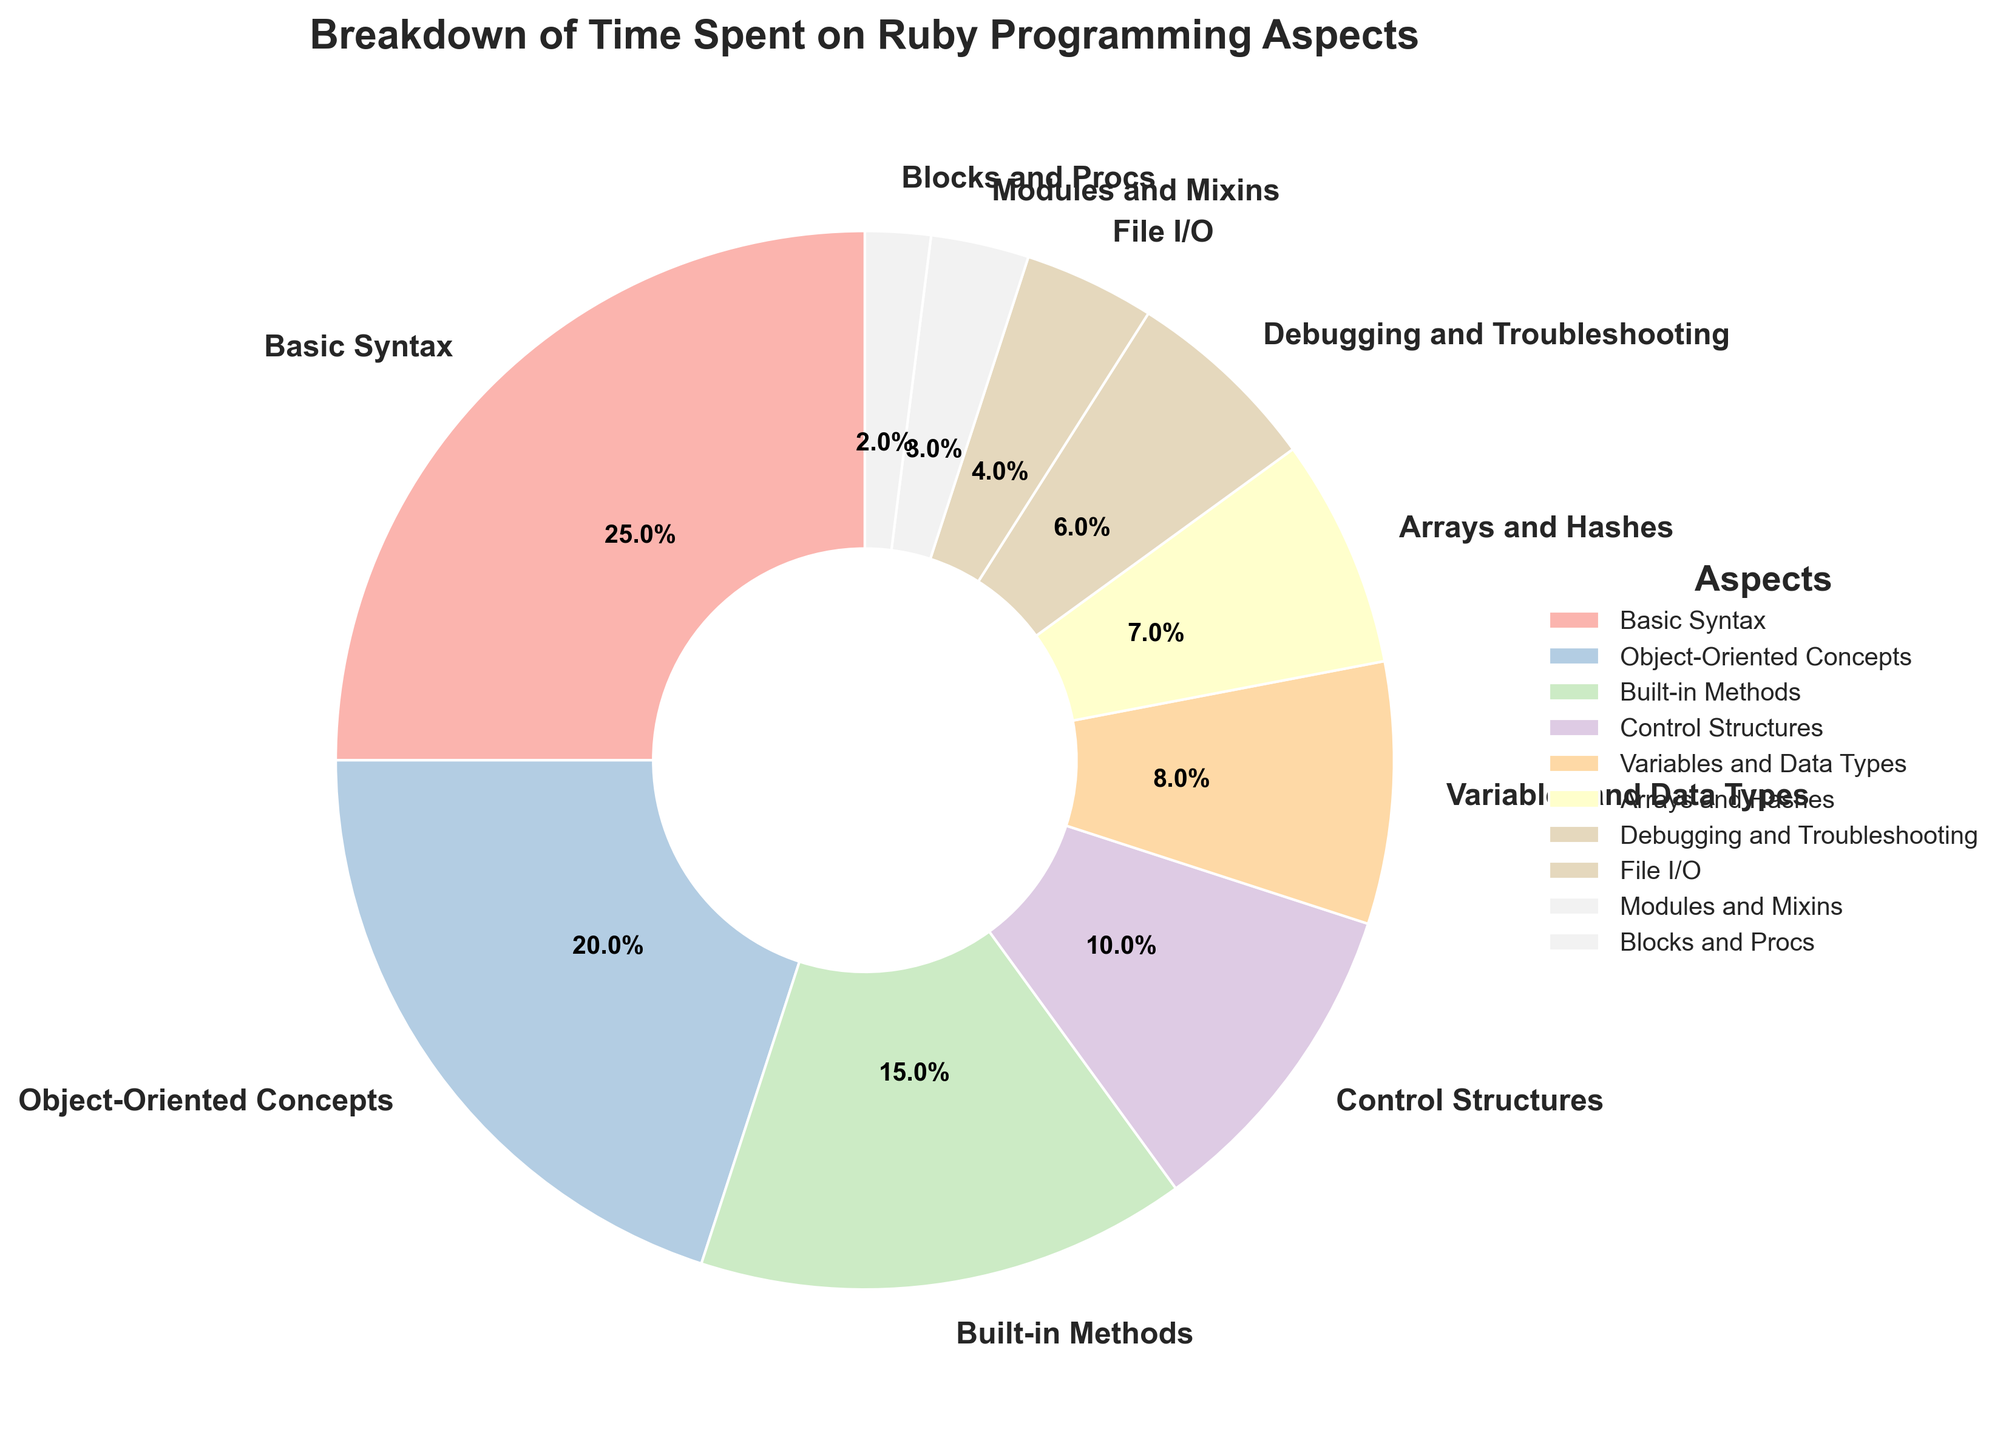What's the total percentage spent on learning control structures and variables and data types? To find the total percentage, add the provided percentages for Control Structures (10) and Variables and Data Types (8). 10 + 8 = 18
Answer: 18% Which aspect takes up more time: debugging and troubleshooting or arrays and hashes? Compare the percentage values for Debugging and Troubleshooting (6) and Arrays and Hashes (7). Arrays and Hashes (7) is greater.
Answer: Arrays and Hashes How much more time is spent on object-oriented concepts compared to built-in methods? Subtract the percentage for Built-in Methods (15) from Object-Oriented Concepts (20). 20 - 15 = 5
Answer: 5% What's the combined percentage of time spent on modules and mixins, and blocks and procs? Add the percentages for Modules and Mixins (3) and Blocks and Procs (2). 3 + 2 = 5
Answer: 5% Which aspect requires the least amount of time? Identify the smallest percentage in the chart, which is for Blocks and Procs (2).
Answer: Blocks and Procs Are Variables and Data Types given more attention than File I/O? Compare the percentages for Variables and Data Types (8) and File I/O (4). Variables and Data Types (8) is greater.
Answer: Yes Is the time spent on array and hashes more than half of the time spent on basic syntax? Divide the percentage for Basic Syntax (25) by 2 to get 12.5. Compare this value with Arrays and Hashes (7). 7 < 12.5
Answer: No What is the difference between the time spent on learning control structures and learning arrays and hashes? Subtract the percentage for Arrays and Hashes (7) from Control Structures (10). 10 - 7 = 3
Answer: 3% Which aspect takes up more time: File I/O or modules and mixins? Compare the percentages for File I/O (4) and Modules and Mixins (3). File I/O (4) is greater.
Answer: File I/O What is the average percentage of time spent on built-in methods, debugging and troubleshooting, and file I/O? Sum the percentages for Built-in Methods (15), Debugging and Troubleshooting (6), and File I/O (4). Then divide by 3. (15 + 6 + 4) / 3 = 25 / 3 ≈ 8.3
Answer: 8.3 